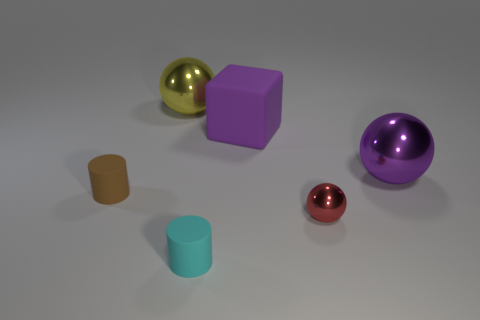Is the number of tiny brown rubber objects that are to the left of the rubber block less than the number of large purple metal spheres?
Give a very brief answer. No. Is there anything else that is the same shape as the tiny brown object?
Offer a very short reply. Yes. The other tiny thing that is the same shape as the small cyan thing is what color?
Provide a succinct answer. Brown. There is a sphere that is in front of the purple shiny sphere; is it the same size as the big yellow metallic object?
Ensure brevity in your answer.  No. There is a rubber cylinder left of the large shiny sphere that is left of the small red sphere; how big is it?
Your answer should be very brief. Small. Is the material of the cube the same as the red sphere in front of the large purple rubber thing?
Offer a very short reply. No. Are there fewer purple spheres to the left of the red metallic object than large things that are behind the large yellow thing?
Offer a very short reply. No. What color is the big cube that is made of the same material as the cyan cylinder?
Your answer should be very brief. Purple. Is there a cylinder behind the brown cylinder to the left of the large matte block?
Give a very brief answer. No. There is another metallic object that is the same size as the yellow thing; what is its color?
Your answer should be very brief. Purple. 